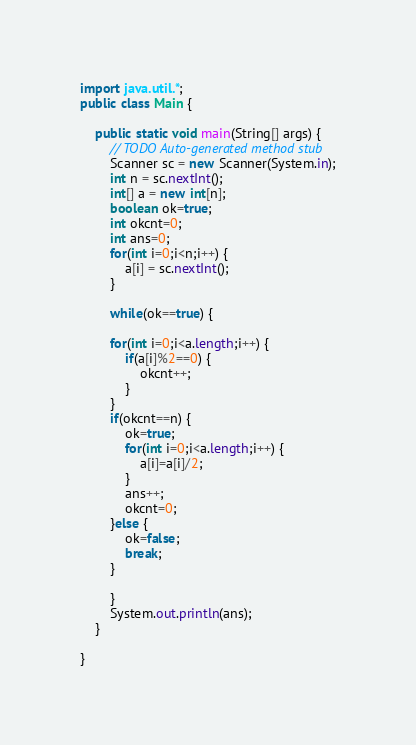<code> <loc_0><loc_0><loc_500><loc_500><_Java_>import java.util.*;
public class Main {

	public static void main(String[] args) {
		// TODO Auto-generated method stub
		Scanner sc = new Scanner(System.in);
		int n = sc.nextInt();
		int[] a = new int[n];
		boolean ok=true;
		int okcnt=0;
		int ans=0;
		for(int i=0;i<n;i++) {
			a[i] = sc.nextInt();
		}
		
		while(ok==true) {
			
		for(int i=0;i<a.length;i++) {
			if(a[i]%2==0) {
				okcnt++;
			}
		}
		if(okcnt==n) {
			ok=true;
			for(int i=0;i<a.length;i++) {
				a[i]=a[i]/2;
			}
			ans++;
			okcnt=0;
		}else {
			ok=false;
			break;
		}
		
		}
		System.out.println(ans);
	}

}
</code> 